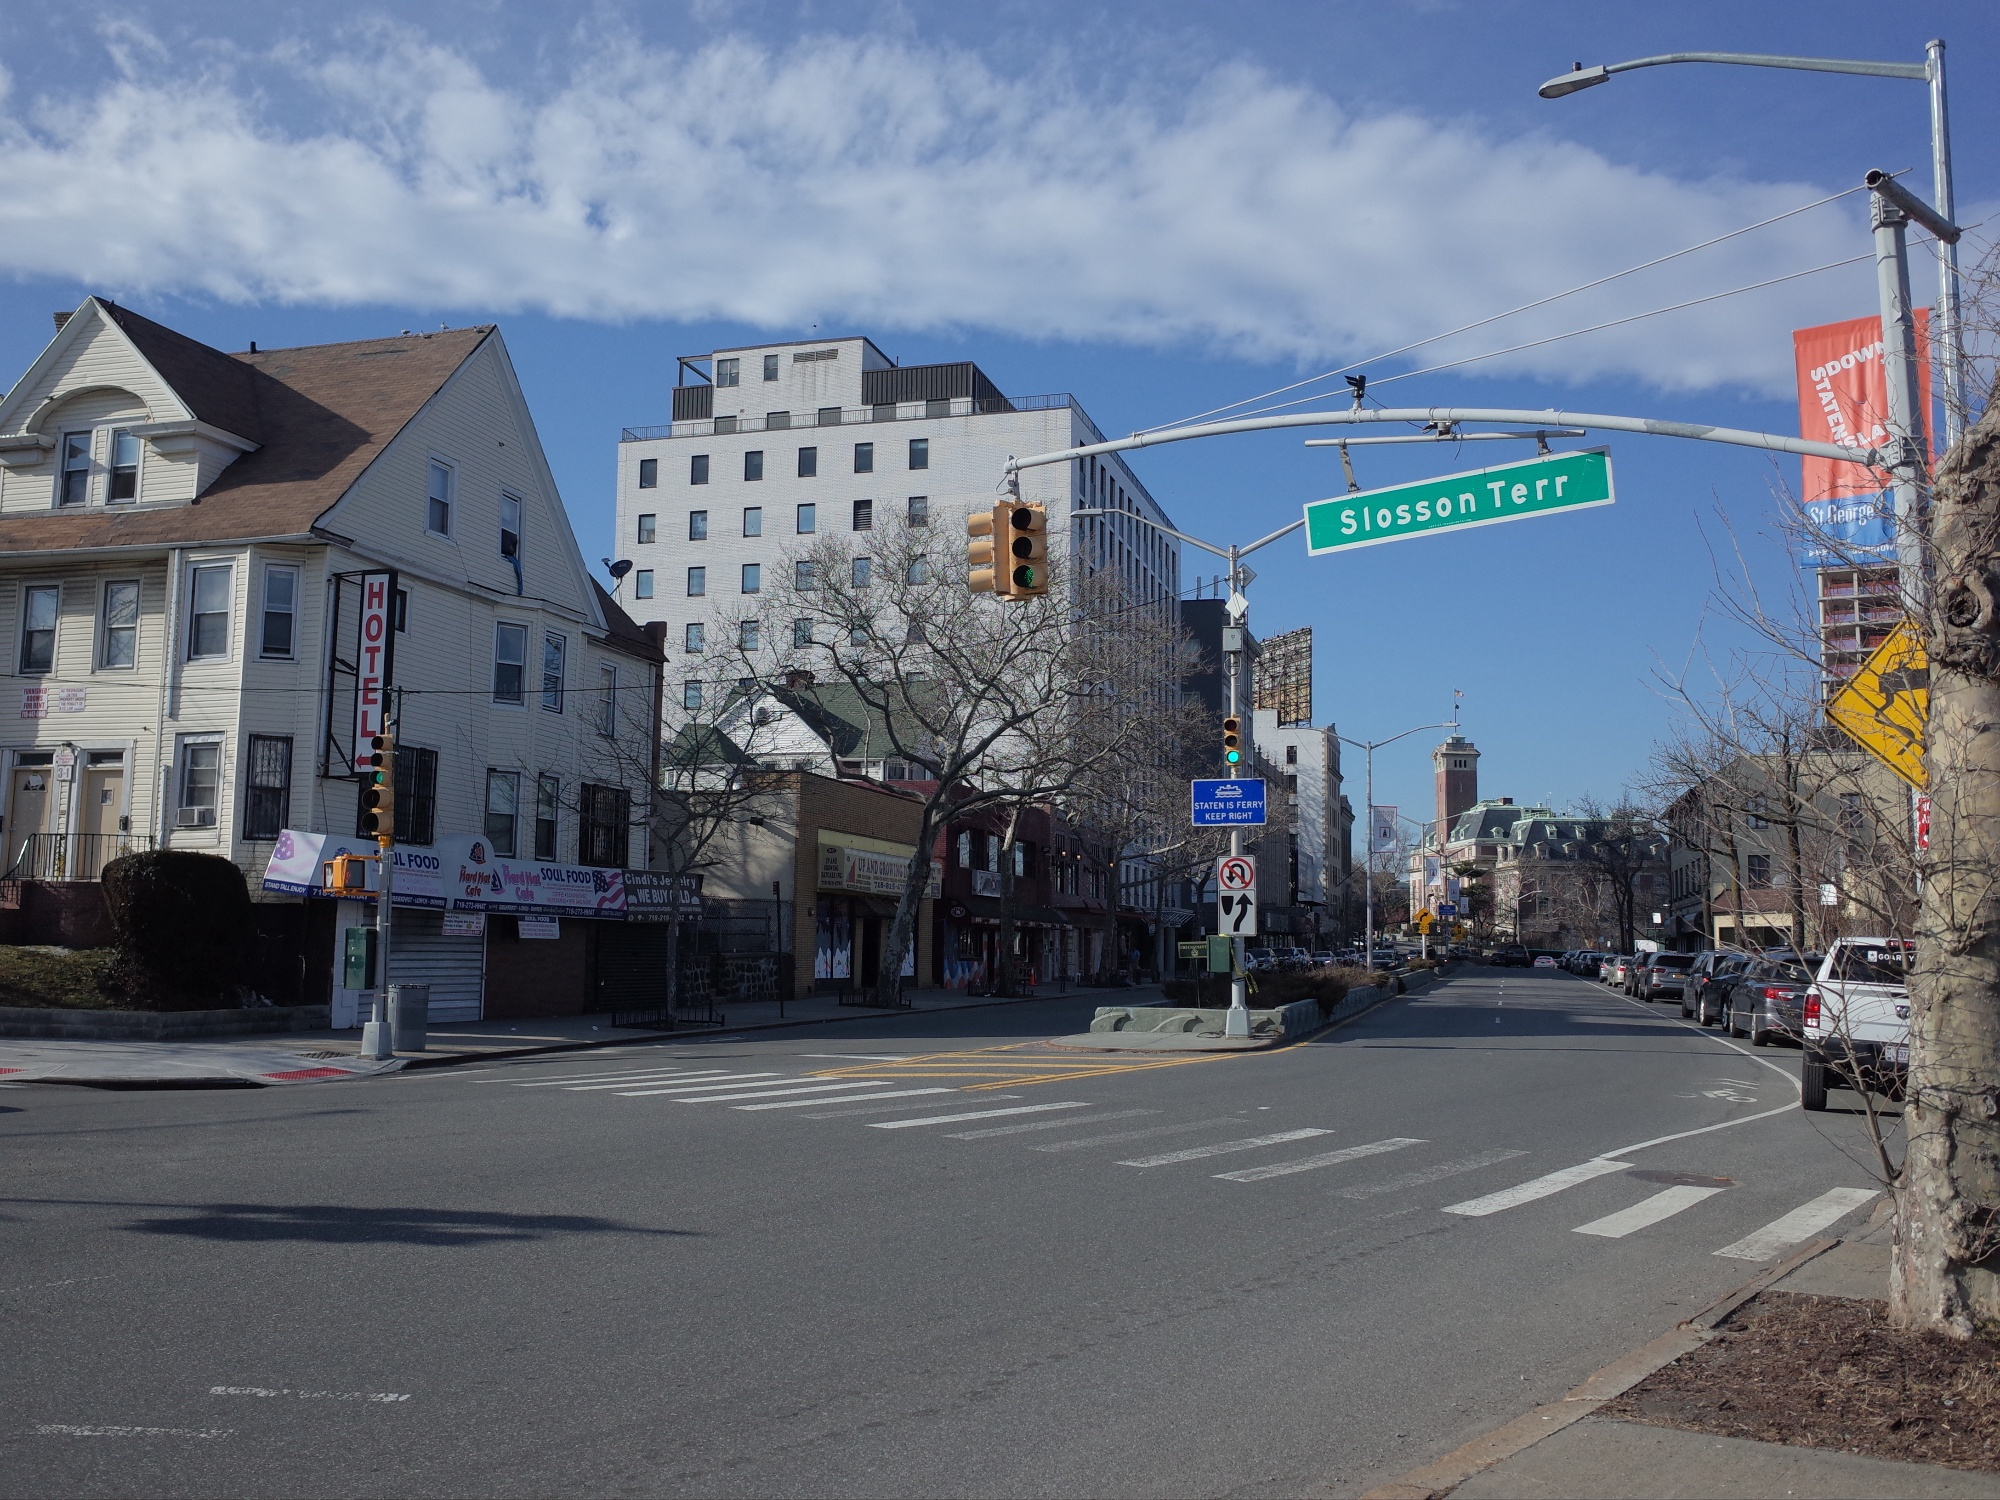If this image were a scene in a movie, what would be happening? In the movie, this scene would capture a pivotal moment of reflection for the protagonist. After a critical turning point in their journey, they find themselves walking alone on Slosson Terrace. The serene stillness of the street contrasts with the turmoil they feel inside. They pause under the signpost of 'Slosson Terrace,' taking a deep breath and looking up at the sky, a symbol of hope and new beginnings. The cityscape around them, from the historical hotel to the modern high-rise, serves as a metaphor for their internal struggle and the dichotomy of past and future. The camera lingers on the fluttering leaves of the trees as the protagonist starts to comprehend this moment of clarity and resolve. How would an artist depict this scene in an exceptionally creative painting? An artist might transform this scene into a whimsical and imaginative painting by adding surreal elements. The buildings could be depicted as towering, imaginative structures that twist and turn in impossible ways, with windows and doors leading to fantastical worlds. The signpost 'Slosson Terrace' could be brightly colored and surrounded by swirling magic dust. The street, devoid of vehicles and pedestrians, might be shown as a flowing river with fishes swimming up and down the intersection. Trees lining the street could have leaves shaped like musical notes, suggesting that the breeze carries a melodic tune. The sky could be filled with floating islands and mythical creatures peeking through the clouds, creating an otherworldly, dreamlike atmosphere. This painting would capture the perfect harmony between reality and fantasy, allowing the viewer to dive deep into their imagination. 